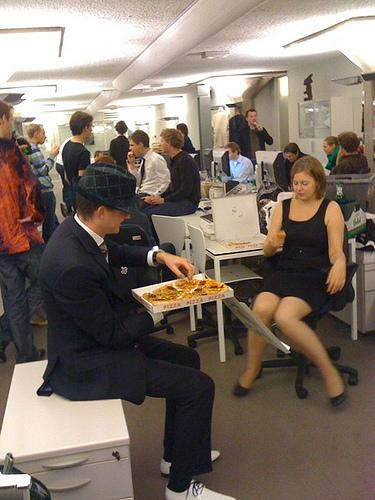Where are people here eating pizza today? Please explain your reasoning. office setting. Seems that there is a meeting going on in the area. 